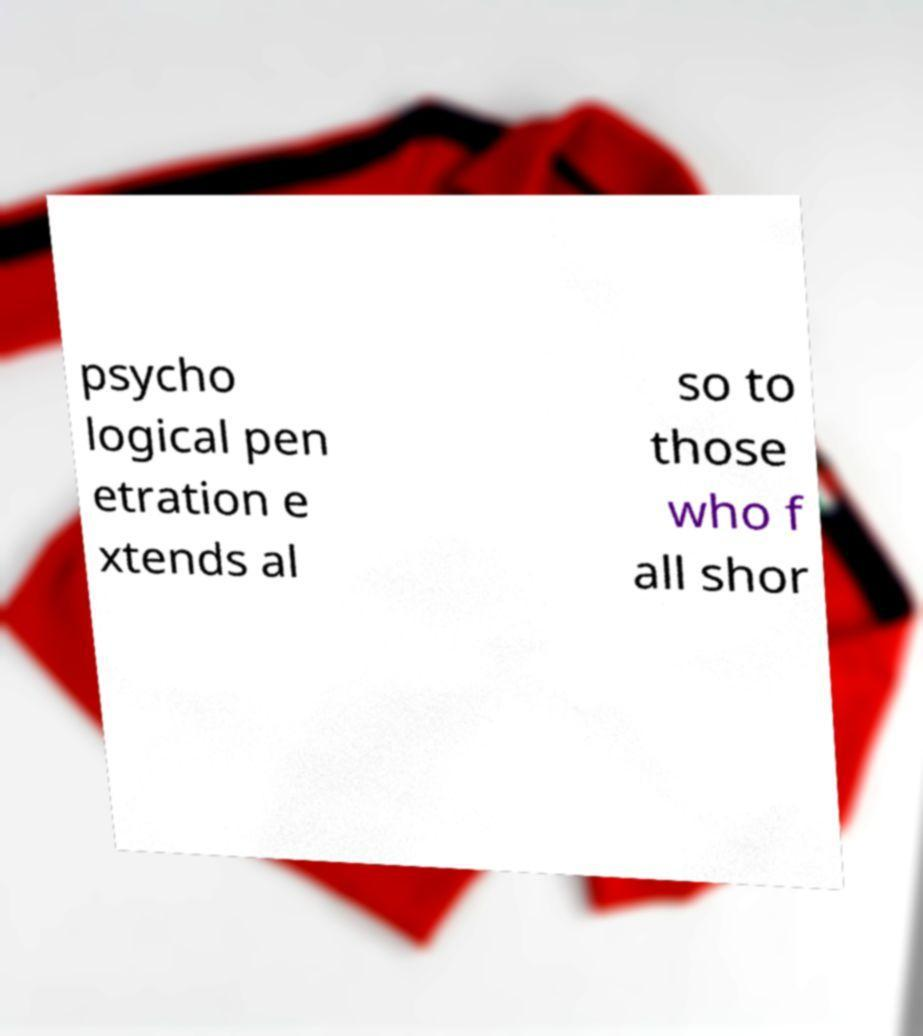I need the written content from this picture converted into text. Can you do that? psycho logical pen etration e xtends al so to those who f all shor 